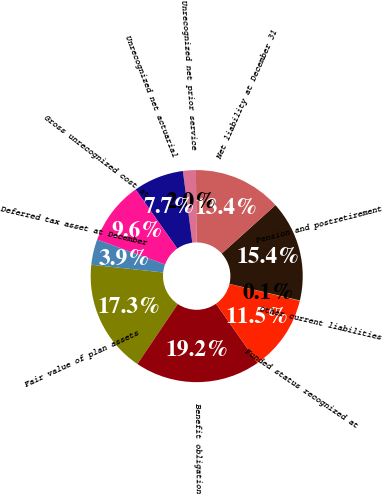Convert chart. <chart><loc_0><loc_0><loc_500><loc_500><pie_chart><fcel>Fair value of plan assets<fcel>Benefit obligation<fcel>Funded status recognized at<fcel>Other current liabilities<fcel>Pension and postretirement<fcel>Net liability at December 31<fcel>Unrecognized net prior service<fcel>Unrecognized net actuarial<fcel>Gross unrecognized cost at<fcel>Deferred tax asset at December<nl><fcel>17.27%<fcel>19.18%<fcel>11.53%<fcel>0.05%<fcel>15.36%<fcel>13.44%<fcel>1.97%<fcel>7.7%<fcel>9.62%<fcel>3.88%<nl></chart> 